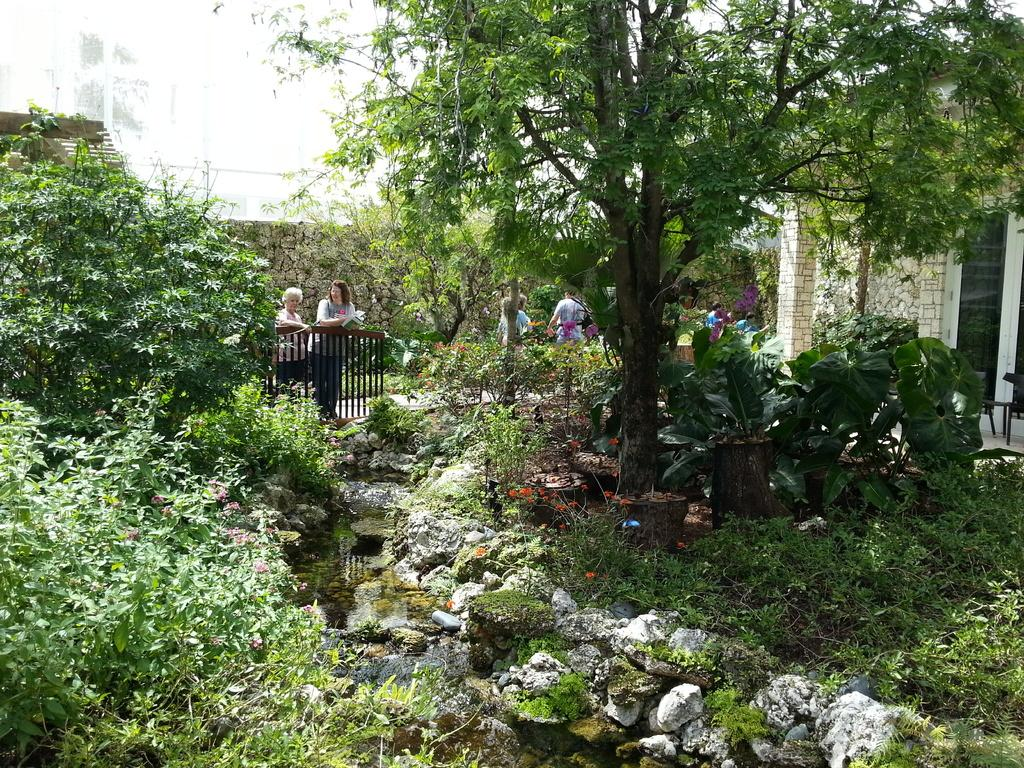What type of natural elements can be seen in the image? There are plants and trees visible in the image. Are there any human elements in the image? Yes, there are people standing in the image. What other objects can be seen in the image? There are rocks and a building visible in the image. What is the presence of water in the image suggest? The presence of water suggests that the image might be near a body of water or in a location with a water source. Can you see a person lighting a match in the image? There is no match or person lighting a match present in the image. What type of sheet is covering the trees in the image? There is no sheet covering the trees in the image; the trees are visible without any covering. 